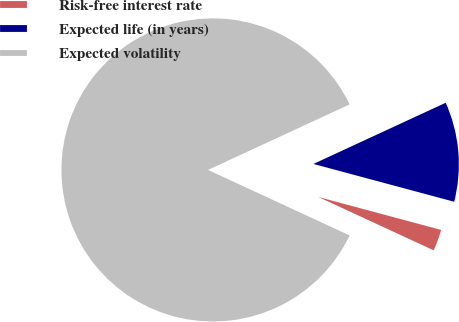Convert chart to OTSL. <chart><loc_0><loc_0><loc_500><loc_500><pie_chart><fcel>Risk-free interest rate<fcel>Expected life (in years)<fcel>Expected volatility<nl><fcel>2.72%<fcel>11.07%<fcel>86.21%<nl></chart> 